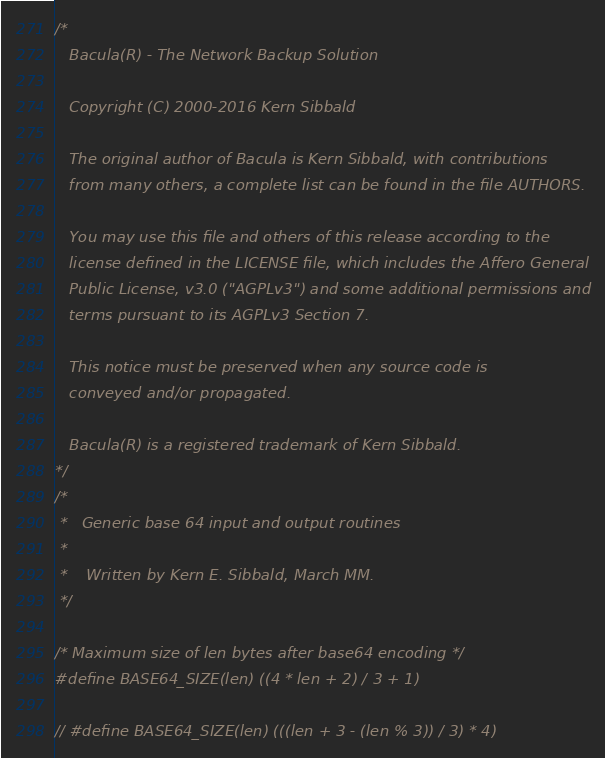<code> <loc_0><loc_0><loc_500><loc_500><_C_>/*
   Bacula(R) - The Network Backup Solution

   Copyright (C) 2000-2016 Kern Sibbald

   The original author of Bacula is Kern Sibbald, with contributions
   from many others, a complete list can be found in the file AUTHORS.

   You may use this file and others of this release according to the
   license defined in the LICENSE file, which includes the Affero General
   Public License, v3.0 ("AGPLv3") and some additional permissions and
   terms pursuant to its AGPLv3 Section 7.

   This notice must be preserved when any source code is 
   conveyed and/or propagated.

   Bacula(R) is a registered trademark of Kern Sibbald.
*/
/*
 *   Generic base 64 input and output routines
 *
 *    Written by Kern E. Sibbald, March MM.
 */

/* Maximum size of len bytes after base64 encoding */
#define BASE64_SIZE(len) ((4 * len + 2) / 3 + 1)

// #define BASE64_SIZE(len) (((len + 3 - (len % 3)) / 3) * 4)
</code> 